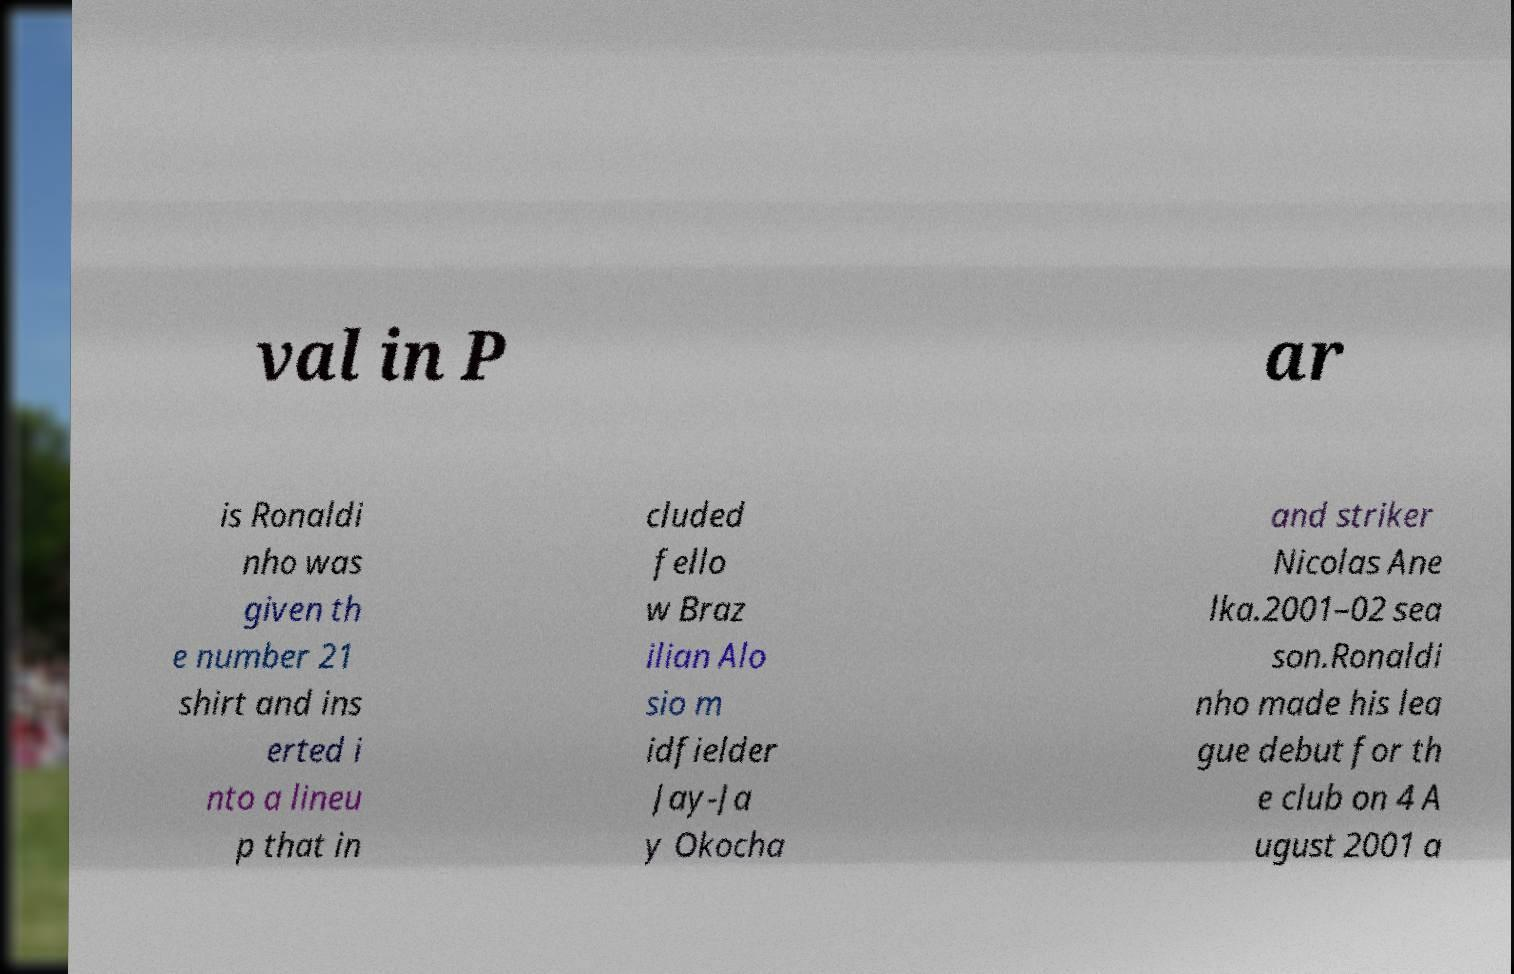Please identify and transcribe the text found in this image. val in P ar is Ronaldi nho was given th e number 21 shirt and ins erted i nto a lineu p that in cluded fello w Braz ilian Alo sio m idfielder Jay-Ja y Okocha and striker Nicolas Ane lka.2001–02 sea son.Ronaldi nho made his lea gue debut for th e club on 4 A ugust 2001 a 